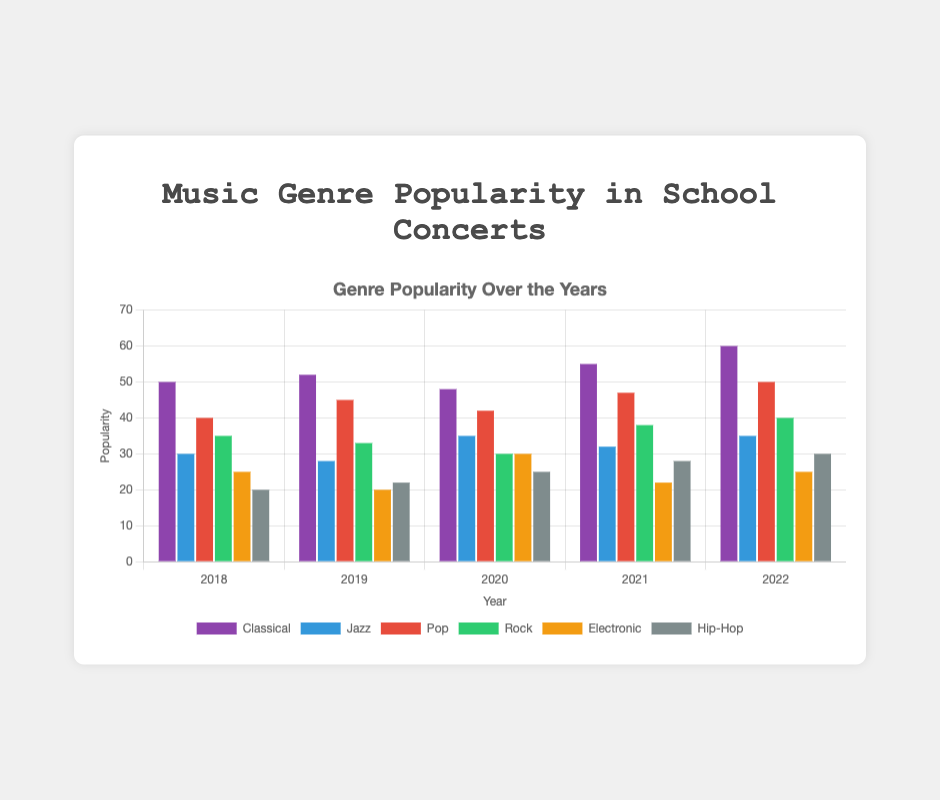what's the most popular genre in 2022? In the 2022 group of bars, identify the tallest bar. Classical has the highest value at 60.
Answer: Classical which genre shows a steady increase from 2018 to 2022? Look at each genre's bars across the years. Hip-Hop consistently increases from 20 in 2018 to 30 in 2022.
Answer: Hip-Hop what is the sum of the popularity of Pop and Rock in 2020? Find the values of Pop and Rock for 2020: Pop is 42, and Rock is 30. Add them together: 42 + 30 = 72.
Answer: 72 which genre had the biggest drop in popularity from 2019 to 2020? Compare the values for each genre in 2019 and 2020. Electronic dropped from 20 to 30, a decrease of 5.
Answer: Electronic what is the difference in popularity between Jazz and Hip-Hop in 2018? In 2018, Jazz is 30 and Hip-Hop is 20. Subtract the Hip-Hop value from the Jazz value: 30 - 20 = 10.
Answer: 10 which year had the highest overall total of all genres combined? Calculate the total for each year: \
2018: 40 + 35 + 50 + 30 + 20 + 25 = 200 \
2019: 45 + 33 + 52 + 28 + 22 + 20 = 200 \
2020: 42 + 30 + 48 + 35 + 25 + 30 = 210 \
2021: 47 + 38 + 55 + 32 + 28 + 22 = 222 \
2022: 50 + 40 + 60 + 35 + 30 + 25 = 240. \
The highest total is in 2022 with 240.
Answer: 2022 which genre peaked in popularity in 2021? Compare the highest values of each genre across all years. Classical peaked in 2021 at 55.
Answer: Classical is the green bar higher than the purple bar in 2020? In 2020, the Rock (green) value is 30, and the Classical (purple) value is 48. Green is not higher than purple.
Answer: No what's the average popularity score for Jazz across all 5 years? Calculate the sum of Jazz values: 30 + 28 + 35 + 32 + 35 = 160. Divide by the number of years: 160 / 5 = 32.
Answer: 32 